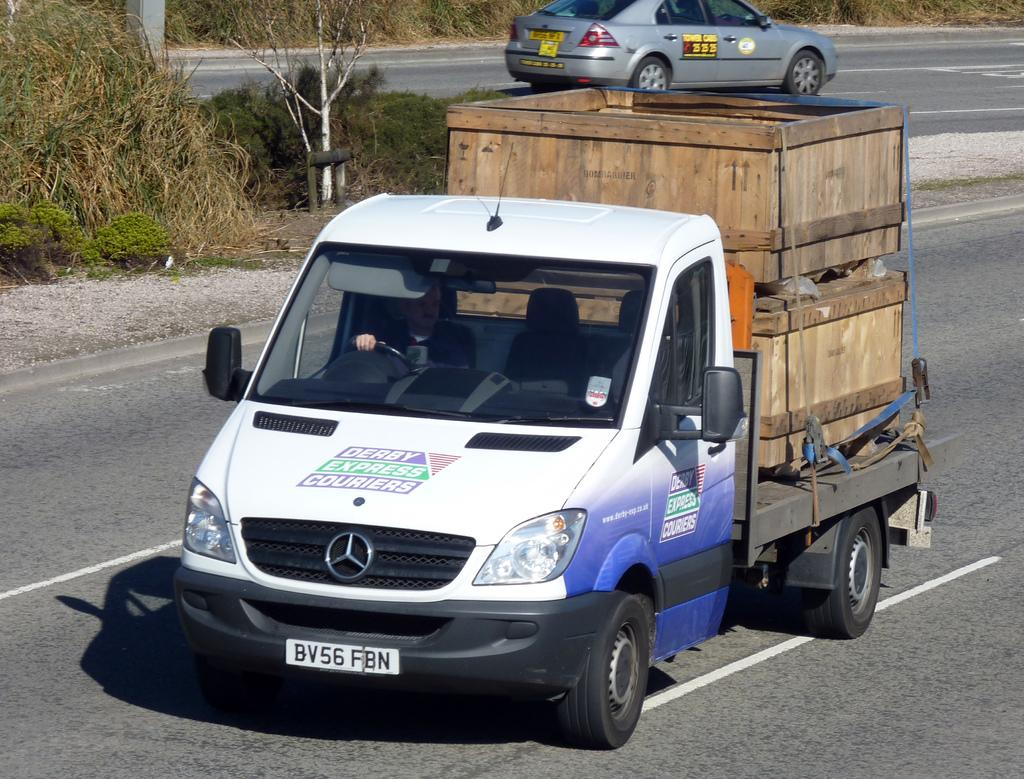<image>
Offer a succinct explanation of the picture presented. Derby Express Carriers are hauling a few crates. 